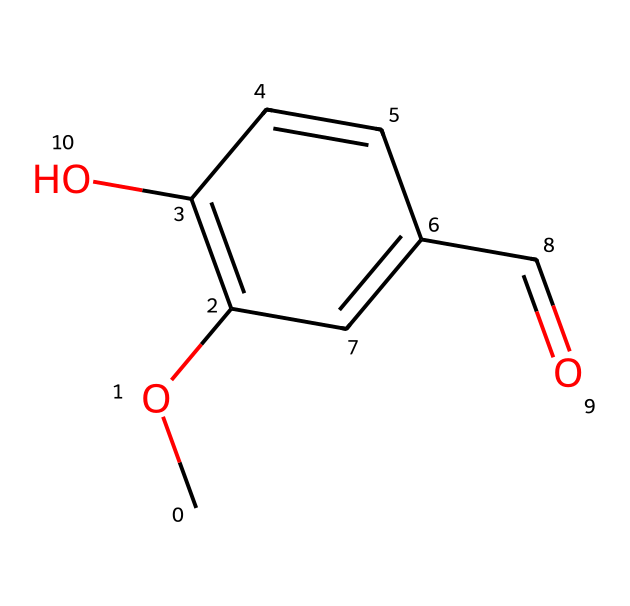What is the molecular formula of vanillin? By analyzing the SMILES representation, COC1=C(C=CC(=C1)C=O)O, we can deduce that it contains carbon (C), hydrogen (H), and oxygen (O) atoms. Counting the atoms gives us 8 carbon atoms, 8 hydrogen atoms, and 3 oxygen atoms. Therefore, the molecular formula is C8H8O3.
Answer: C8H8O3 How many rings are present in vanillin's structure? The SMILES notation indicates the presence of a cyclic structure, which is denoted by the "C1" and "C1" indicating a ring closure. In this case, there is one ring present in the structure of vanillin.
Answer: 1 What functional group is indicated by the "C=O" in vanillin? The "C=O" notation represents a carbonyl group, which is characteristic of aldehydes and ketones. In this context, it indicates that vanillin has an aldehyde functional group since it is at the end of the carbon chain.
Answer: aldehyde What type of hybridization does the carbon atom in the C=O group have? The carbon atom involved in the C=O group exhibits sp2 hybridization. This occurs because there is a double bond between the carbon and oxygen, and the carbon forms three sigma bonds in total, leading to sp2 hybridization.
Answer: sp2 Which part of the structure gives vanillin its sweet flavor? The molecular structure contains the aldehyde functional group, which is known to impart a sweet flavor to certain compounds. Therefore, the aldehyde functional group is responsible for the sweet flavor of vanillin.
Answer: aldehyde How many total atoms are present in the vanillin molecule? The total number of atoms in vanillin can be calculated by adding the counts of each atom type from the molecular formula (C8H8O3). This sums up to 8 (C) + 8 (H) + 3 (O) = 19 total atoms.
Answer: 19 